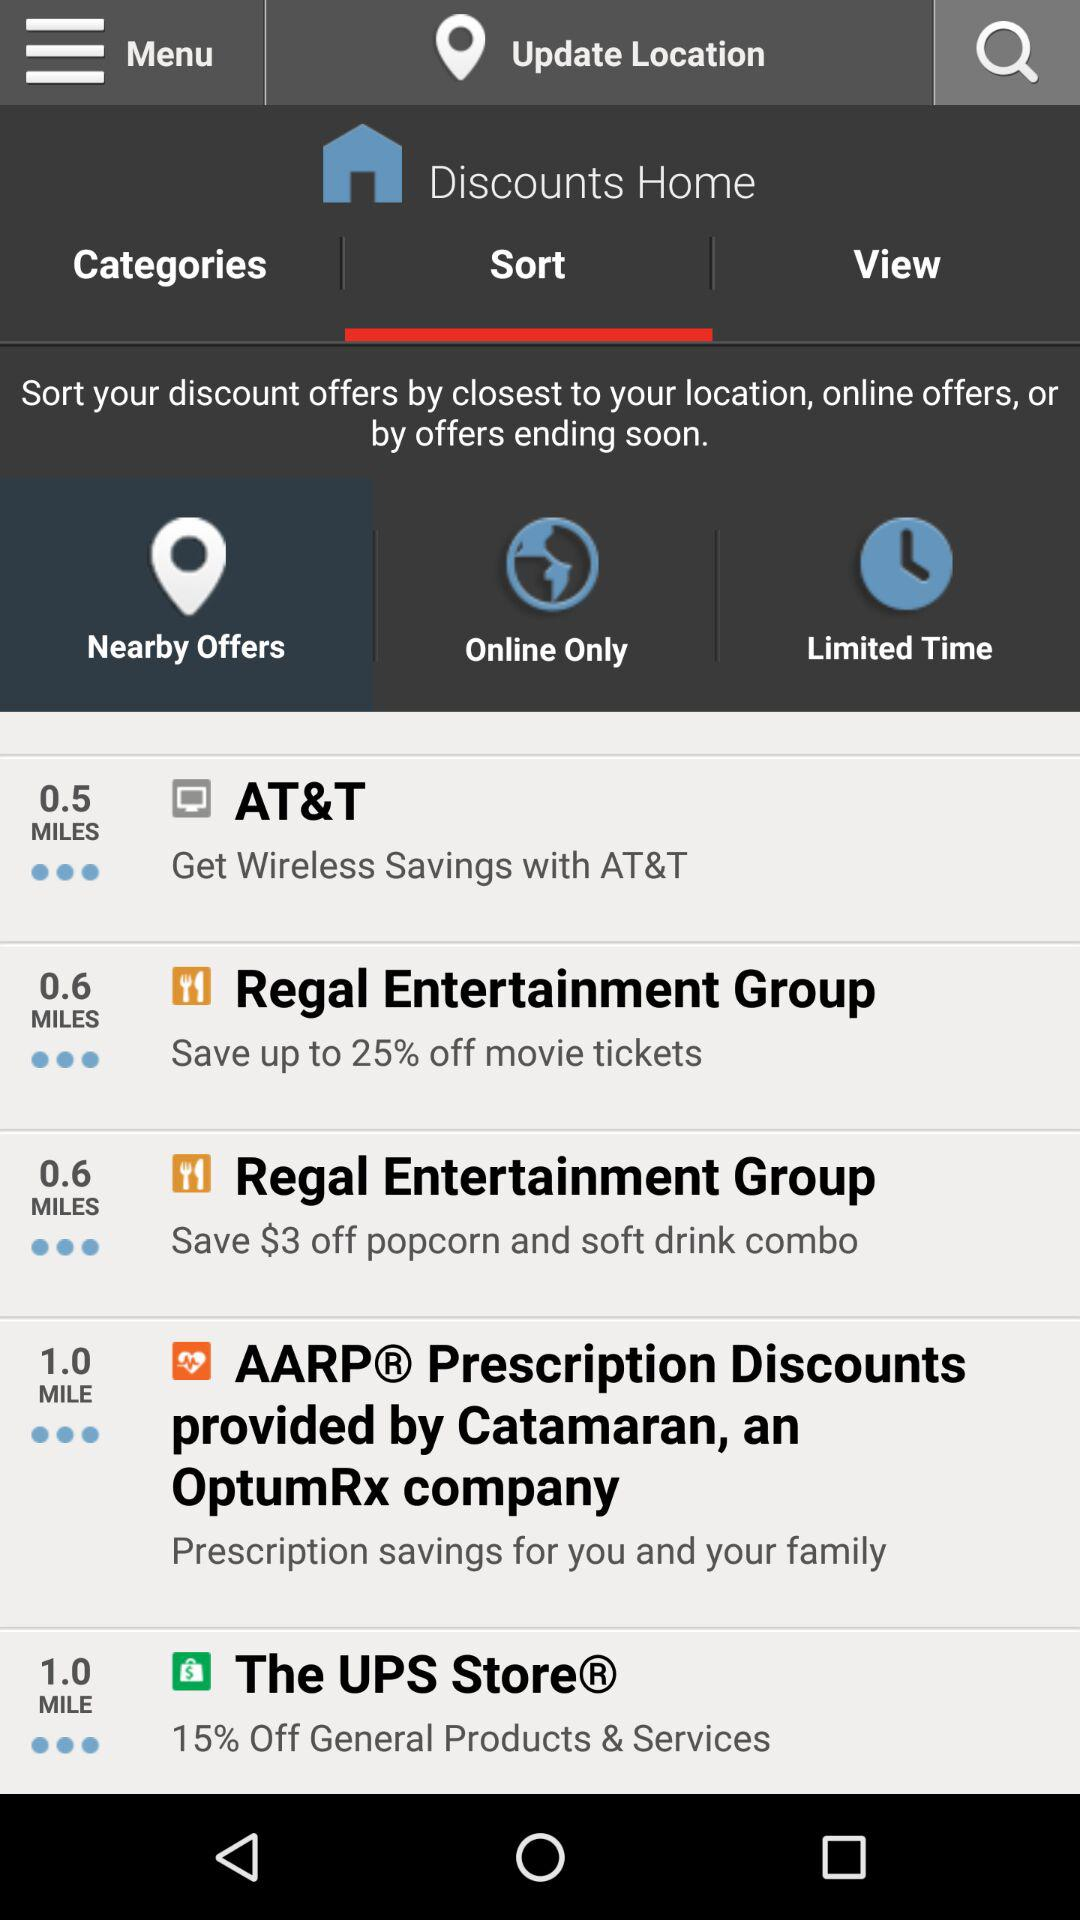How much can we save on movie tickets? You can save up to 25 percent on movie tickets. 